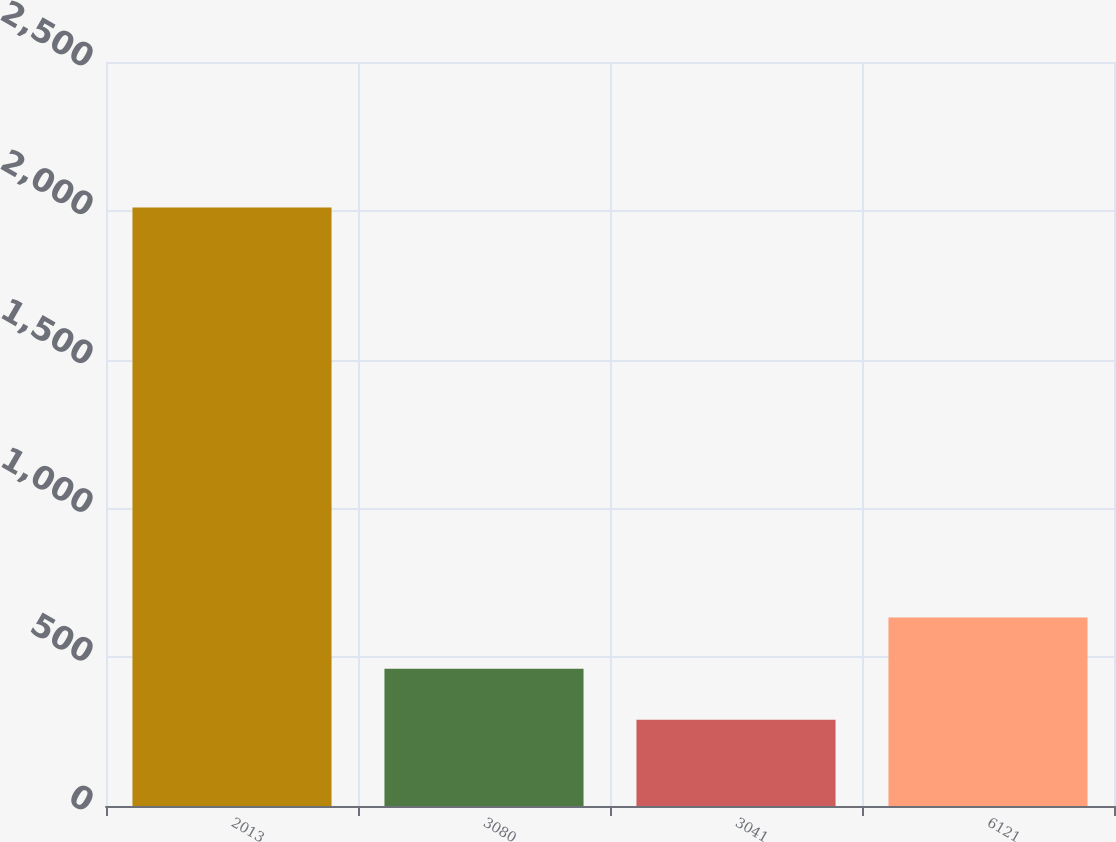<chart> <loc_0><loc_0><loc_500><loc_500><bar_chart><fcel>2013<fcel>3080<fcel>3041<fcel>6121<nl><fcel>2011<fcel>461.56<fcel>289.4<fcel>633.72<nl></chart> 